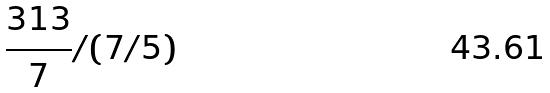Convert formula to latex. <formula><loc_0><loc_0><loc_500><loc_500>\frac { 3 1 3 } { 7 } / ( 7 / 5 )</formula> 